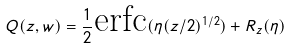Convert formula to latex. <formula><loc_0><loc_0><loc_500><loc_500>Q ( z , w ) = \frac { 1 } { 2 } \text {erfc} ( \eta ( z / 2 ) ^ { 1 / 2 } ) + R _ { z } ( \eta )</formula> 